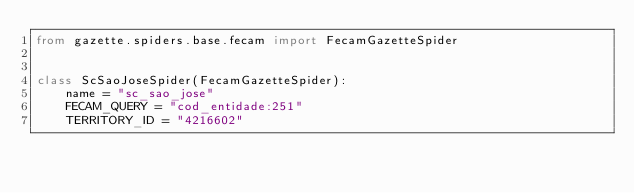<code> <loc_0><loc_0><loc_500><loc_500><_Python_>from gazette.spiders.base.fecam import FecamGazetteSpider


class ScSaoJoseSpider(FecamGazetteSpider):
    name = "sc_sao_jose"
    FECAM_QUERY = "cod_entidade:251"
    TERRITORY_ID = "4216602"
</code> 